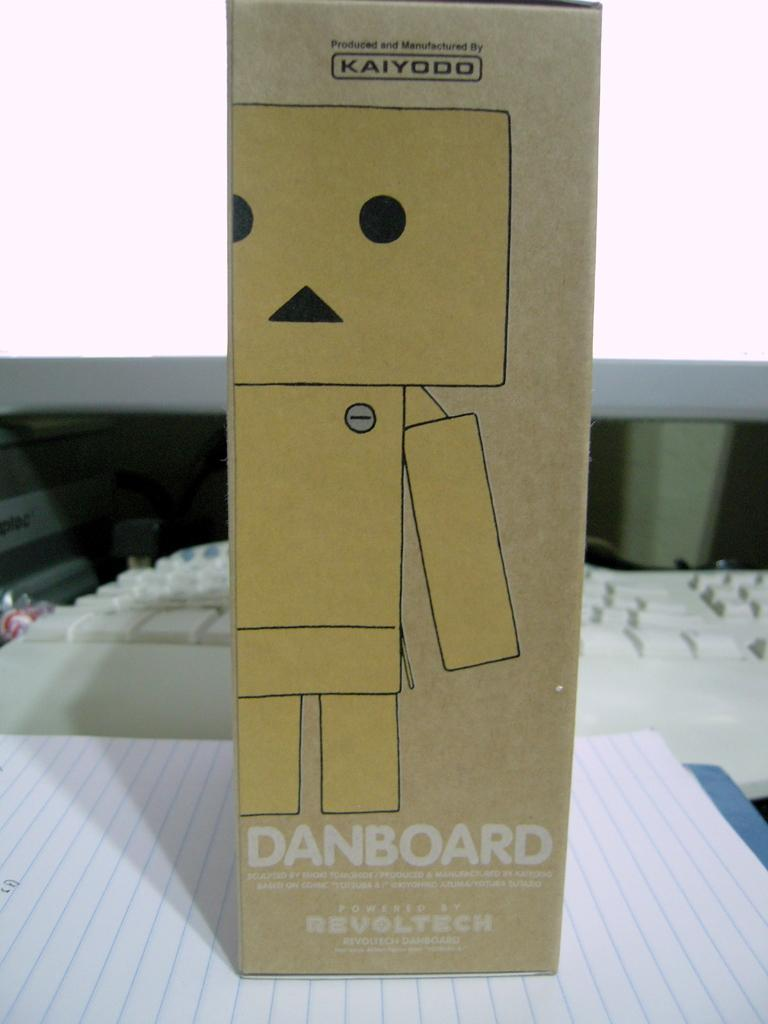<image>
Give a short and clear explanation of the subsequent image. A cardboard box with a picture of a robot and the word Danboard written on it sits on top of some lined paper.. 